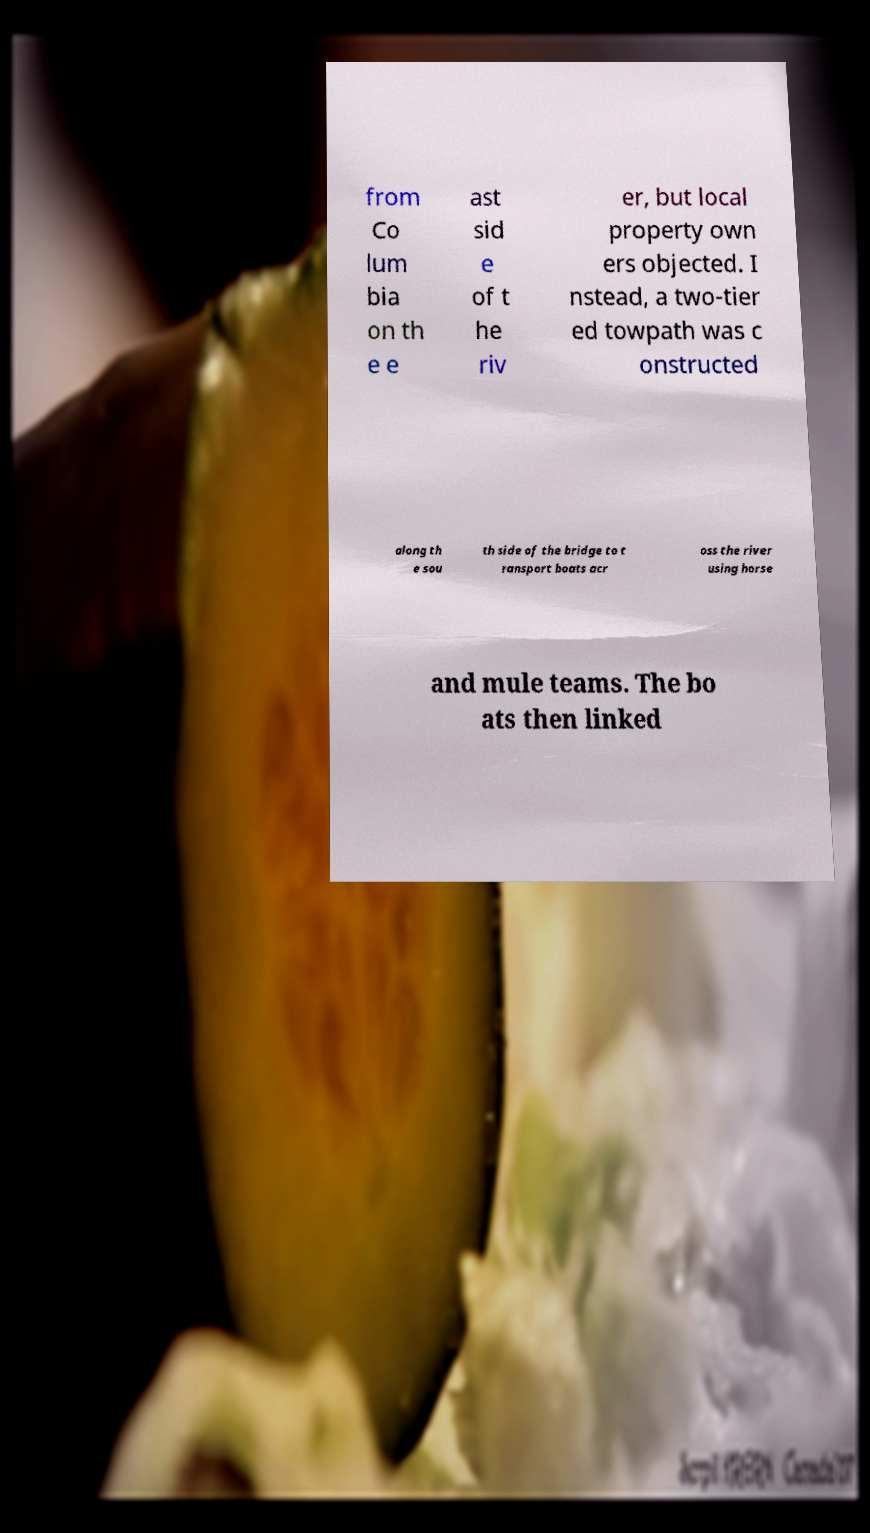What messages or text are displayed in this image? I need them in a readable, typed format. from Co lum bia on th e e ast sid e of t he riv er, but local property own ers objected. I nstead, a two-tier ed towpath was c onstructed along th e sou th side of the bridge to t ransport boats acr oss the river using horse and mule teams. The bo ats then linked 